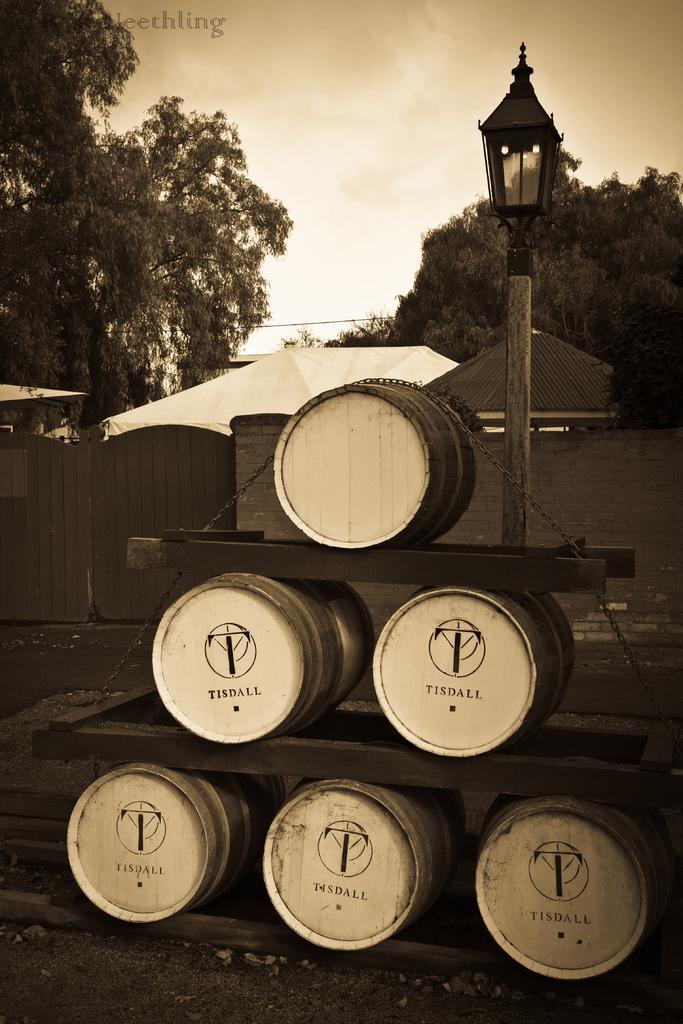In one or two sentences, can you explain what this image depicts? In this image we can see barrels on wooden pieces. Also there is a light pole. And there is chain on the barrel. In the back there are trees. Also there are tents and there is a wall with a gate. In the background there is sky. 